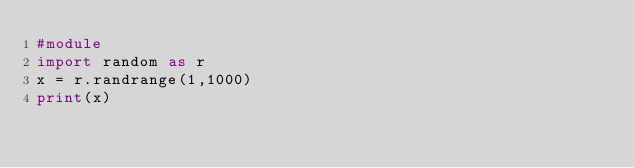Convert code to text. <code><loc_0><loc_0><loc_500><loc_500><_Python_>#module
import random as r
x = r.randrange(1,1000)
print(x)
</code> 